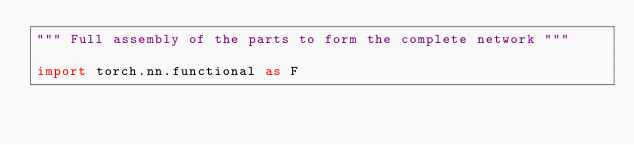<code> <loc_0><loc_0><loc_500><loc_500><_Python_>""" Full assembly of the parts to form the complete network """

import torch.nn.functional as F
</code> 